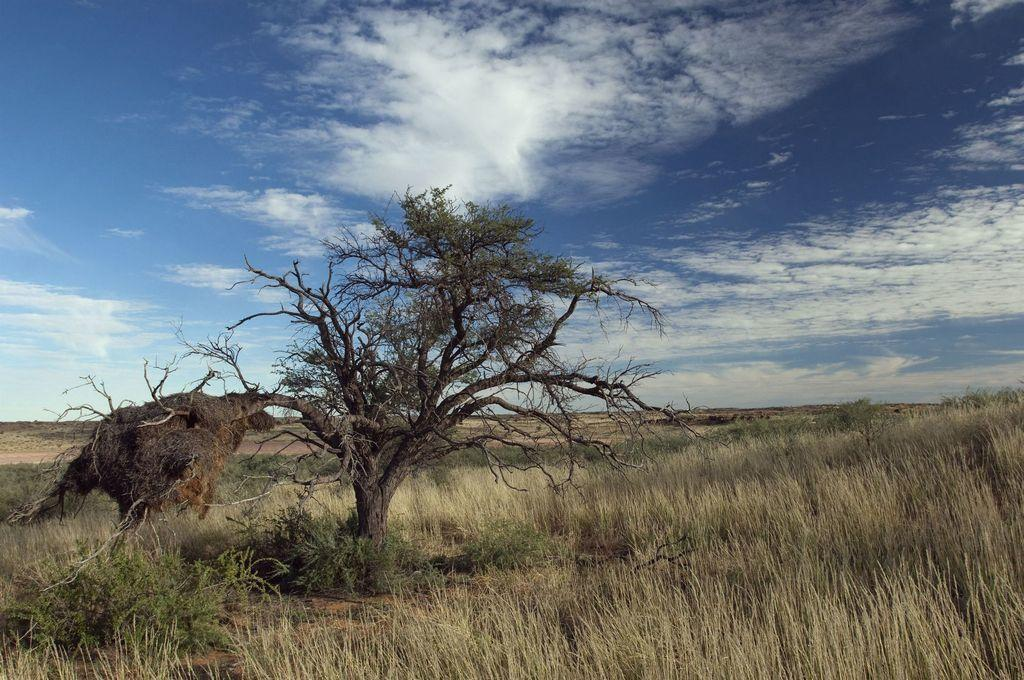What is the main subject in the middle of the image? There is a tree in the middle of the image. What type of vegetation can be seen at the base of the tree? There is grass visible in the image. What is the condition of the sky in the image? The sky is sunny and visible at the top of the image. What type of list can be seen hanging from the tree in the image? There is no list present in the image; it features a tree, grass, and a sunny sky. Can you tell me how many stalks of celery are visible in the image? There is no celery present in the image. 